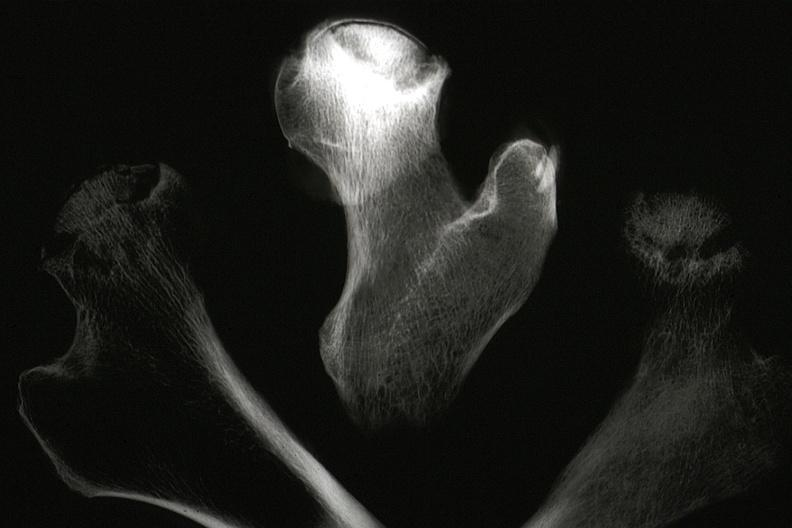what is present?
Answer the question using a single word or phrase. Joints 